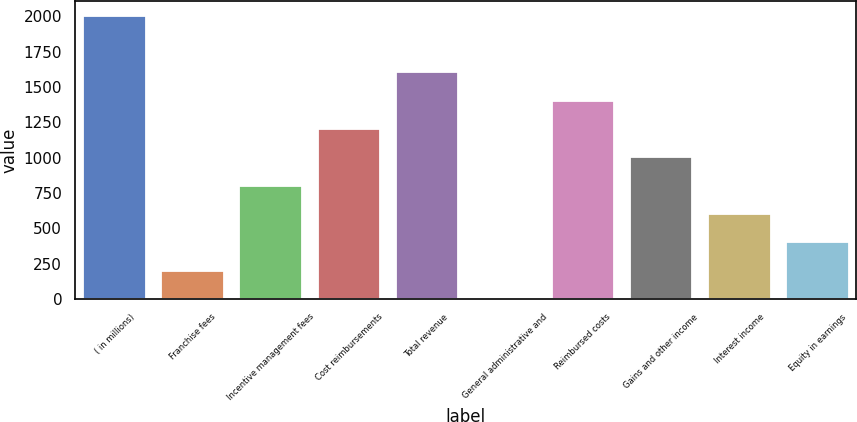Convert chart to OTSL. <chart><loc_0><loc_0><loc_500><loc_500><bar_chart><fcel>( in millions)<fcel>Franchise fees<fcel>Incentive management fees<fcel>Cost reimbursements<fcel>Total revenue<fcel>General administrative and<fcel>Reimbursed costs<fcel>Gains and other income<fcel>Interest income<fcel>Equity in earnings<nl><fcel>2006<fcel>201.5<fcel>803<fcel>1204<fcel>1605<fcel>1<fcel>1404.5<fcel>1003.5<fcel>602.5<fcel>402<nl></chart> 